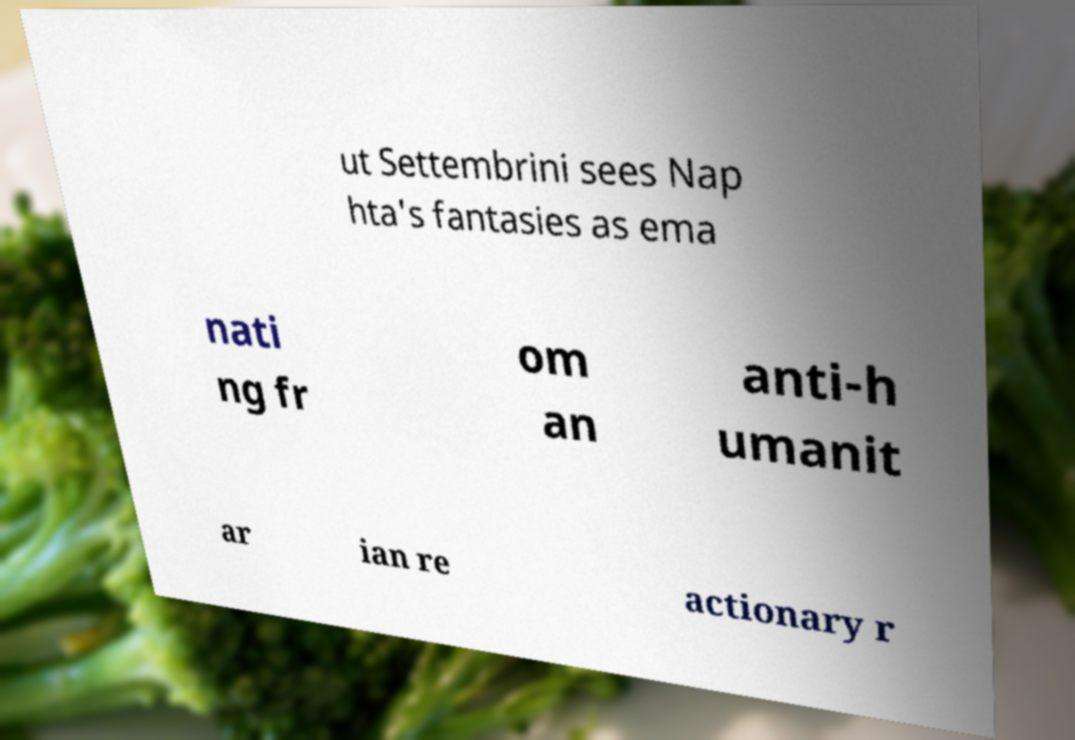There's text embedded in this image that I need extracted. Can you transcribe it verbatim? ut Settembrini sees Nap hta's fantasies as ema nati ng fr om an anti-h umanit ar ian re actionary r 